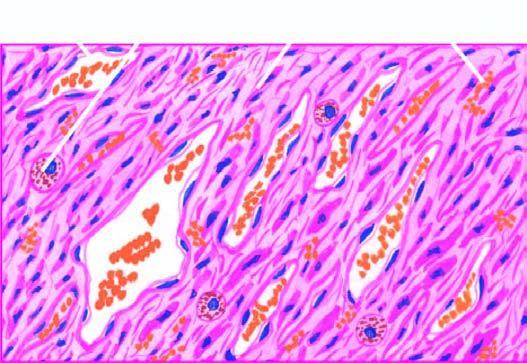where are present bands of plump spindle-shaped tumour cells?
Answer the question using a single word or phrase. Between slit-like blood-filled vascular spaces 